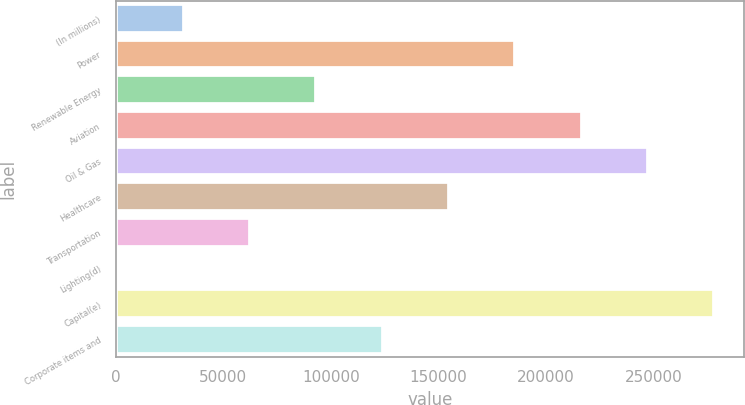Convert chart to OTSL. <chart><loc_0><loc_0><loc_500><loc_500><bar_chart><fcel>(In millions)<fcel>Power<fcel>Renewable Energy<fcel>Aviation<fcel>Oil & Gas<fcel>Healthcare<fcel>Transportation<fcel>Lighting(d)<fcel>Capital(e)<fcel>Corporate items and<nl><fcel>31542<fcel>185757<fcel>93228<fcel>216600<fcel>247443<fcel>154914<fcel>62385<fcel>699<fcel>278286<fcel>124071<nl></chart> 